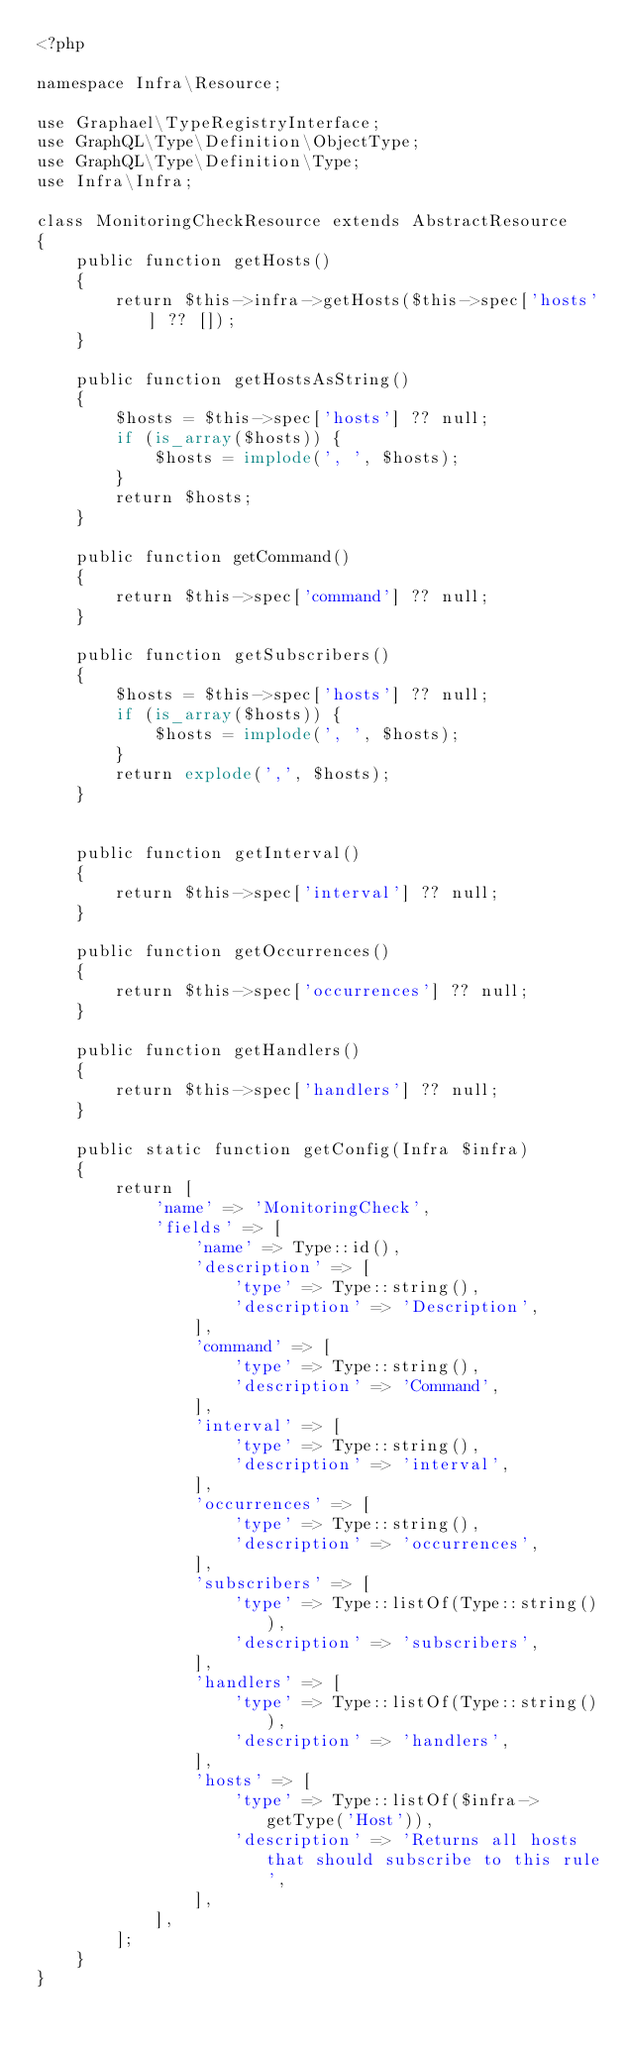Convert code to text. <code><loc_0><loc_0><loc_500><loc_500><_PHP_><?php

namespace Infra\Resource;

use Graphael\TypeRegistryInterface;
use GraphQL\Type\Definition\ObjectType;
use GraphQL\Type\Definition\Type;
use Infra\Infra;

class MonitoringCheckResource extends AbstractResource
{
    public function getHosts()
    {
        return $this->infra->getHosts($this->spec['hosts'] ?? []);
    }

    public function getHostsAsString()
    {
        $hosts = $this->spec['hosts'] ?? null;
        if (is_array($hosts)) {
            $hosts = implode(', ', $hosts);
        }
        return $hosts;
    }
    
    public function getCommand()
    {
        return $this->spec['command'] ?? null;
    }

    public function getSubscribers()
    {
        $hosts = $this->spec['hosts'] ?? null;
        if (is_array($hosts)) {
            $hosts = implode(', ', $hosts);
        }
        return explode(',', $hosts);
    }


    public function getInterval()
    {
        return $this->spec['interval'] ?? null;
    }

    public function getOccurrences()
    {
        return $this->spec['occurrences'] ?? null;
    }

    public function getHandlers()
    {
        return $this->spec['handlers'] ?? null;
    }

    public static function getConfig(Infra $infra)
    {
        return [
            'name' => 'MonitoringCheck',
            'fields' => [
                'name' => Type::id(),
                'description' => [
                    'type' => Type::string(),
                    'description' => 'Description',
                ],
                'command' => [
                    'type' => Type::string(),
                    'description' => 'Command',
                ],
                'interval' => [
                    'type' => Type::string(),
                    'description' => 'interval',
                ],
                'occurrences' => [
                    'type' => Type::string(),
                    'description' => 'occurrences',
                ],
                'subscribers' => [
                    'type' => Type::listOf(Type::string()),
                    'description' => 'subscribers',
                ],
                'handlers' => [
                    'type' => Type::listOf(Type::string()),
                    'description' => 'handlers',
                ],
                'hosts' => [
                    'type' => Type::listOf($infra->getType('Host')),
                    'description' => 'Returns all hosts that should subscribe to this rule',
                ],
            ],
        ];
    }
}
</code> 